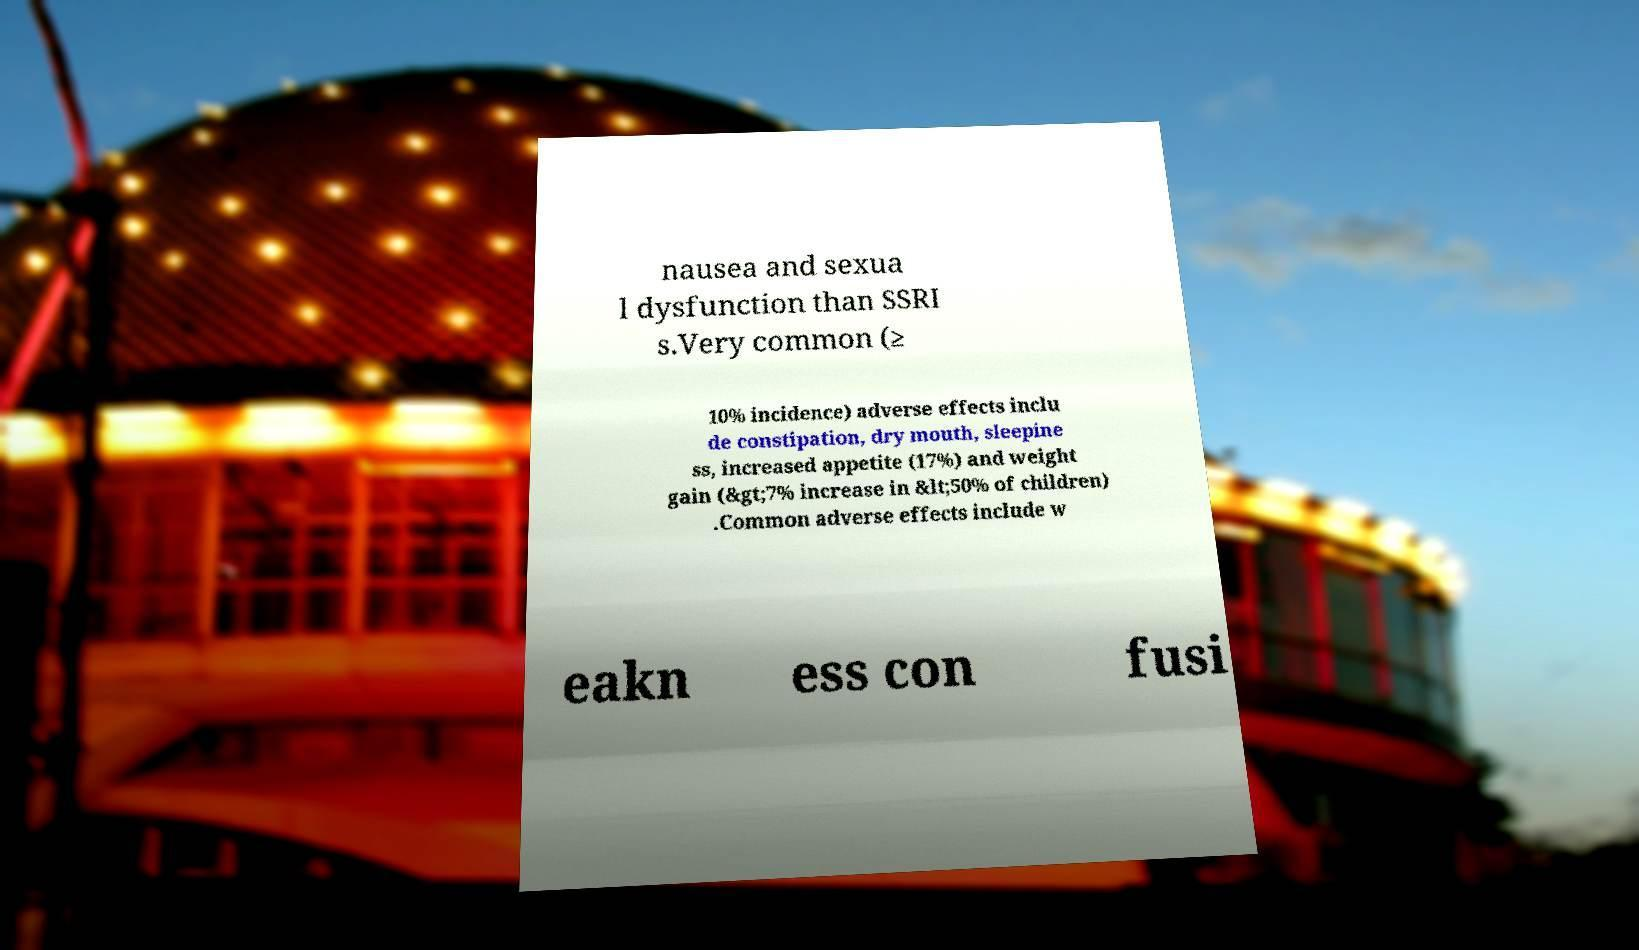Please read and relay the text visible in this image. What does it say? nausea and sexua l dysfunction than SSRI s.Very common (≥ 10% incidence) adverse effects inclu de constipation, dry mouth, sleepine ss, increased appetite (17%) and weight gain (&gt;7% increase in &lt;50% of children) .Common adverse effects include w eakn ess con fusi 